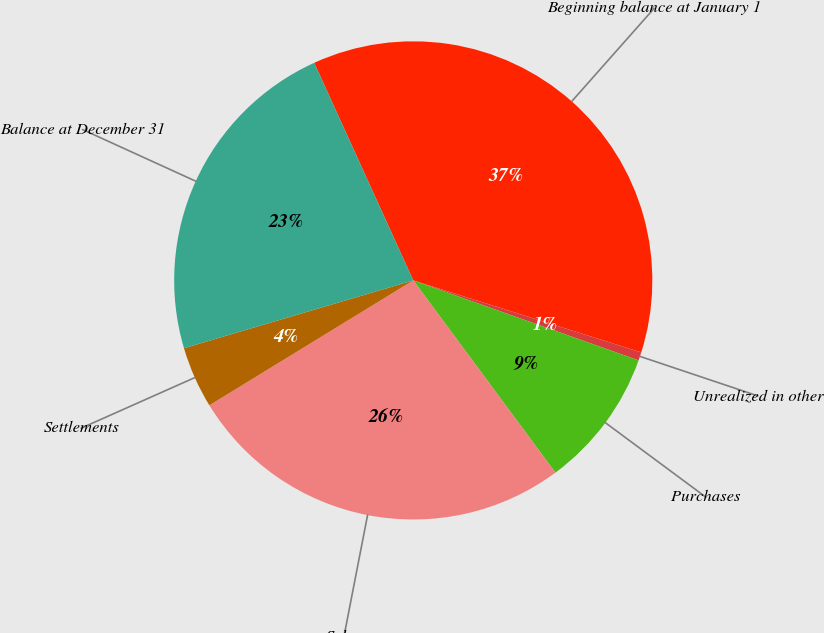<chart> <loc_0><loc_0><loc_500><loc_500><pie_chart><fcel>Beginning balance at January 1<fcel>Unrealized in other<fcel>Purchases<fcel>Sales<fcel>Settlements<fcel>Balance at December 31<nl><fcel>36.67%<fcel>0.56%<fcel>9.44%<fcel>26.39%<fcel>4.17%<fcel>22.78%<nl></chart> 